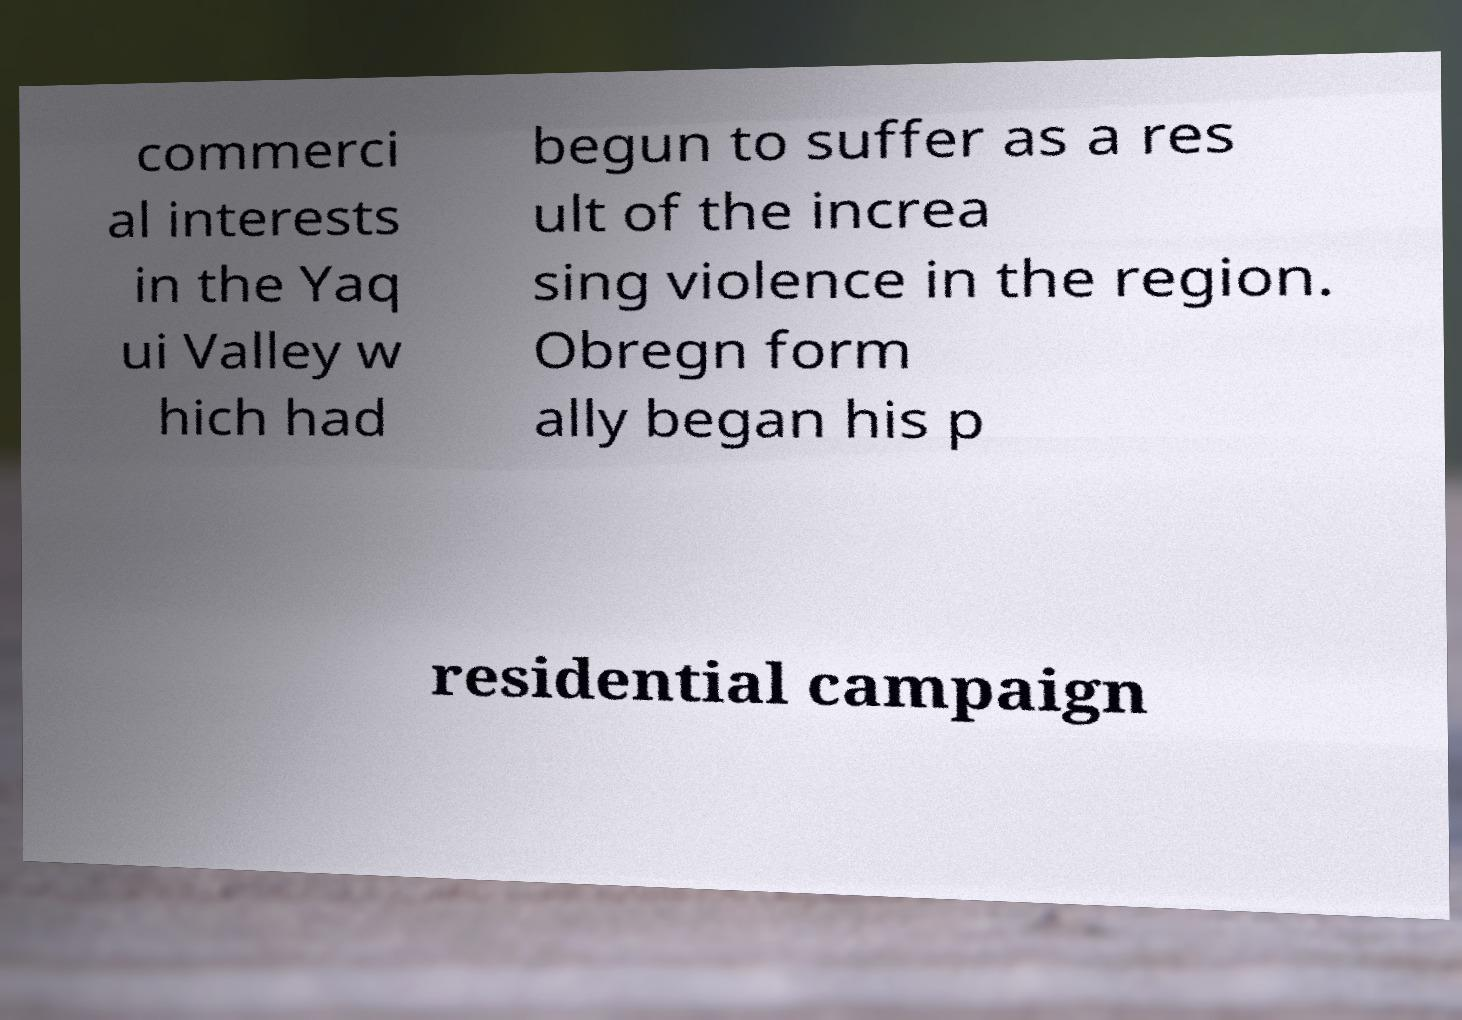For documentation purposes, I need the text within this image transcribed. Could you provide that? commerci al interests in the Yaq ui Valley w hich had begun to suffer as a res ult of the increa sing violence in the region. Obregn form ally began his p residential campaign 